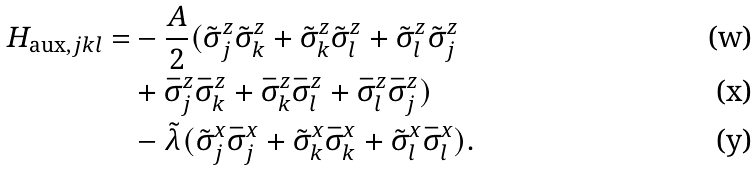Convert formula to latex. <formula><loc_0><loc_0><loc_500><loc_500>H _ { \text {aux} , j k l } = & - \frac { A } { 2 } ( \tilde { \sigma } _ { j } ^ { z } \tilde { \sigma } _ { k } ^ { z } + \tilde { \sigma } _ { k } ^ { z } \tilde { \sigma } _ { l } ^ { z } + \tilde { \sigma } _ { l } ^ { z } \tilde { \sigma } _ { j } ^ { z } \\ & + \bar { \sigma } _ { j } ^ { z } \bar { \sigma } _ { k } ^ { z } + \bar { \sigma } _ { k } ^ { z } \bar { \sigma } _ { l } ^ { z } + \bar { \sigma } _ { l } ^ { z } \bar { \sigma } _ { j } ^ { z } ) \\ & - \tilde { \lambda } ( \tilde { \sigma } _ { j } ^ { x } \bar { \sigma } _ { j } ^ { x } + \tilde { \sigma } _ { k } ^ { x } \bar { \sigma } _ { k } ^ { x } + \tilde { \sigma } _ { l } ^ { x } \bar { \sigma } _ { l } ^ { x } ) .</formula> 